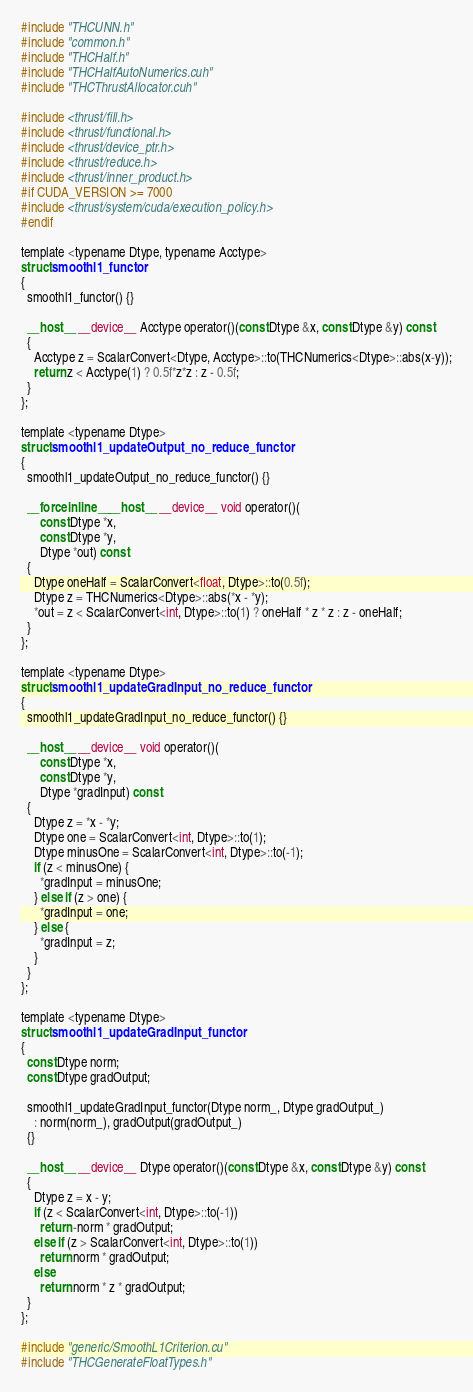<code> <loc_0><loc_0><loc_500><loc_500><_Cuda_>#include "THCUNN.h"
#include "common.h"
#include "THCHalf.h"
#include "THCHalfAutoNumerics.cuh"
#include "THCThrustAllocator.cuh"

#include <thrust/fill.h>
#include <thrust/functional.h>
#include <thrust/device_ptr.h>
#include <thrust/reduce.h>
#include <thrust/inner_product.h>
#if CUDA_VERSION >= 7000
#include <thrust/system/cuda/execution_policy.h>
#endif

template <typename Dtype, typename Acctype>
struct smoothl1_functor
{
  smoothl1_functor() {}

  __host__ __device__ Acctype operator()(const Dtype &x, const Dtype &y) const
  {
    Acctype z = ScalarConvert<Dtype, Acctype>::to(THCNumerics<Dtype>::abs(x-y));
    return z < Acctype(1) ? 0.5f*z*z : z - 0.5f;
  }
};

template <typename Dtype>
struct smoothl1_updateOutput_no_reduce_functor
{
  smoothl1_updateOutput_no_reduce_functor() {}

  __forceinline__ __host__ __device__ void operator()(
      const Dtype *x, 
      const Dtype *y,
      Dtype *out) const
  {
    Dtype oneHalf = ScalarConvert<float, Dtype>::to(0.5f);
    Dtype z = THCNumerics<Dtype>::abs(*x - *y);
    *out = z < ScalarConvert<int, Dtype>::to(1) ? oneHalf * z * z : z - oneHalf;
  }
};

template <typename Dtype>
struct smoothl1_updateGradInput_no_reduce_functor
{
  smoothl1_updateGradInput_no_reduce_functor() {}

  __host__ __device__ void operator()(
      const Dtype *x, 
      const Dtype *y,
      Dtype *gradInput) const
  {
    Dtype z = *x - *y;
    Dtype one = ScalarConvert<int, Dtype>::to(1);
    Dtype minusOne = ScalarConvert<int, Dtype>::to(-1);
    if (z < minusOne) {
      *gradInput = minusOne;
    } else if (z > one) {
      *gradInput = one;
    } else {
      *gradInput = z;
    }
  }
};

template <typename Dtype>
struct smoothl1_updateGradInput_functor
{
  const Dtype norm;
  const Dtype gradOutput;

  smoothl1_updateGradInput_functor(Dtype norm_, Dtype gradOutput_)
    : norm(norm_), gradOutput(gradOutput_)
  {}

  __host__ __device__ Dtype operator()(const Dtype &x, const Dtype &y) const
  {
    Dtype z = x - y;
    if (z < ScalarConvert<int, Dtype>::to(-1))
      return -norm * gradOutput;
    else if (z > ScalarConvert<int, Dtype>::to(1))
      return norm * gradOutput;
    else
      return norm * z * gradOutput;
  }
};

#include "generic/SmoothL1Criterion.cu"
#include "THCGenerateFloatTypes.h"
</code> 